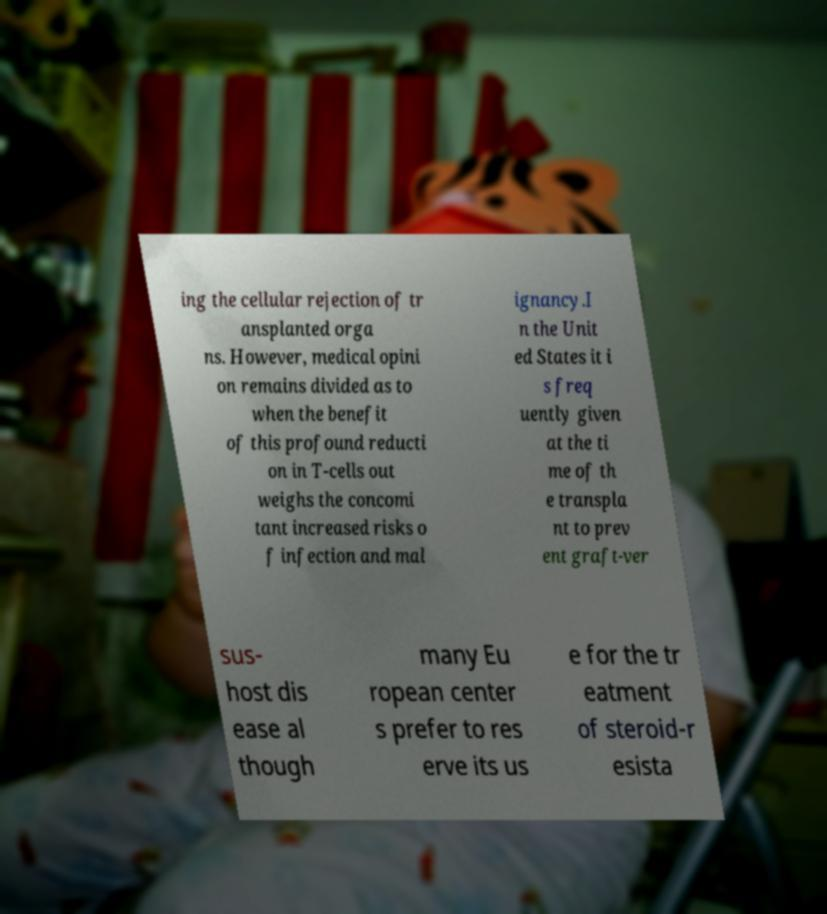I need the written content from this picture converted into text. Can you do that? ing the cellular rejection of tr ansplanted orga ns. However, medical opini on remains divided as to when the benefit of this profound reducti on in T-cells out weighs the concomi tant increased risks o f infection and mal ignancy.I n the Unit ed States it i s freq uently given at the ti me of th e transpla nt to prev ent graft-ver sus- host dis ease al though many Eu ropean center s prefer to res erve its us e for the tr eatment of steroid-r esista 